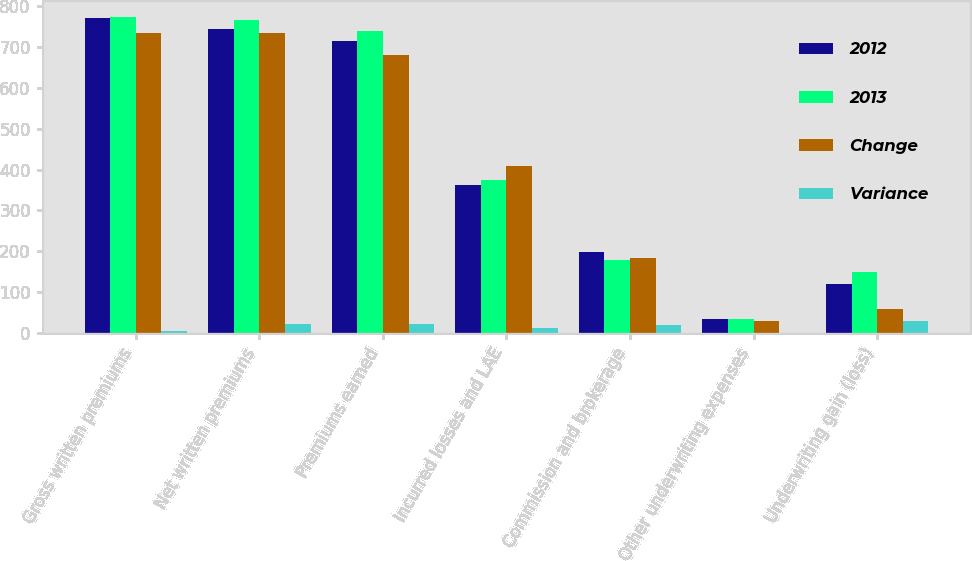Convert chart. <chart><loc_0><loc_0><loc_500><loc_500><stacked_bar_chart><ecel><fcel>Gross written premiums<fcel>Net written premiums<fcel>Premiums earned<fcel>Incurred losses and LAE<fcel>Commission and brokerage<fcel>Other underwriting expenses<fcel>Underwriting gain (loss)<nl><fcel>2012<fcel>770.2<fcel>744.7<fcel>715.7<fcel>361.8<fcel>198.8<fcel>34.9<fcel>120.2<nl><fcel>2013<fcel>774.3<fcel>765.7<fcel>738<fcel>374.4<fcel>179.1<fcel>34.7<fcel>149.8<nl><fcel>Change<fcel>734.4<fcel>733.8<fcel>680.9<fcel>408.2<fcel>184.4<fcel>30.6<fcel>57.8<nl><fcel>Variance<fcel>4<fcel>21<fcel>22.3<fcel>12.6<fcel>19.7<fcel>0.3<fcel>29.6<nl></chart> 